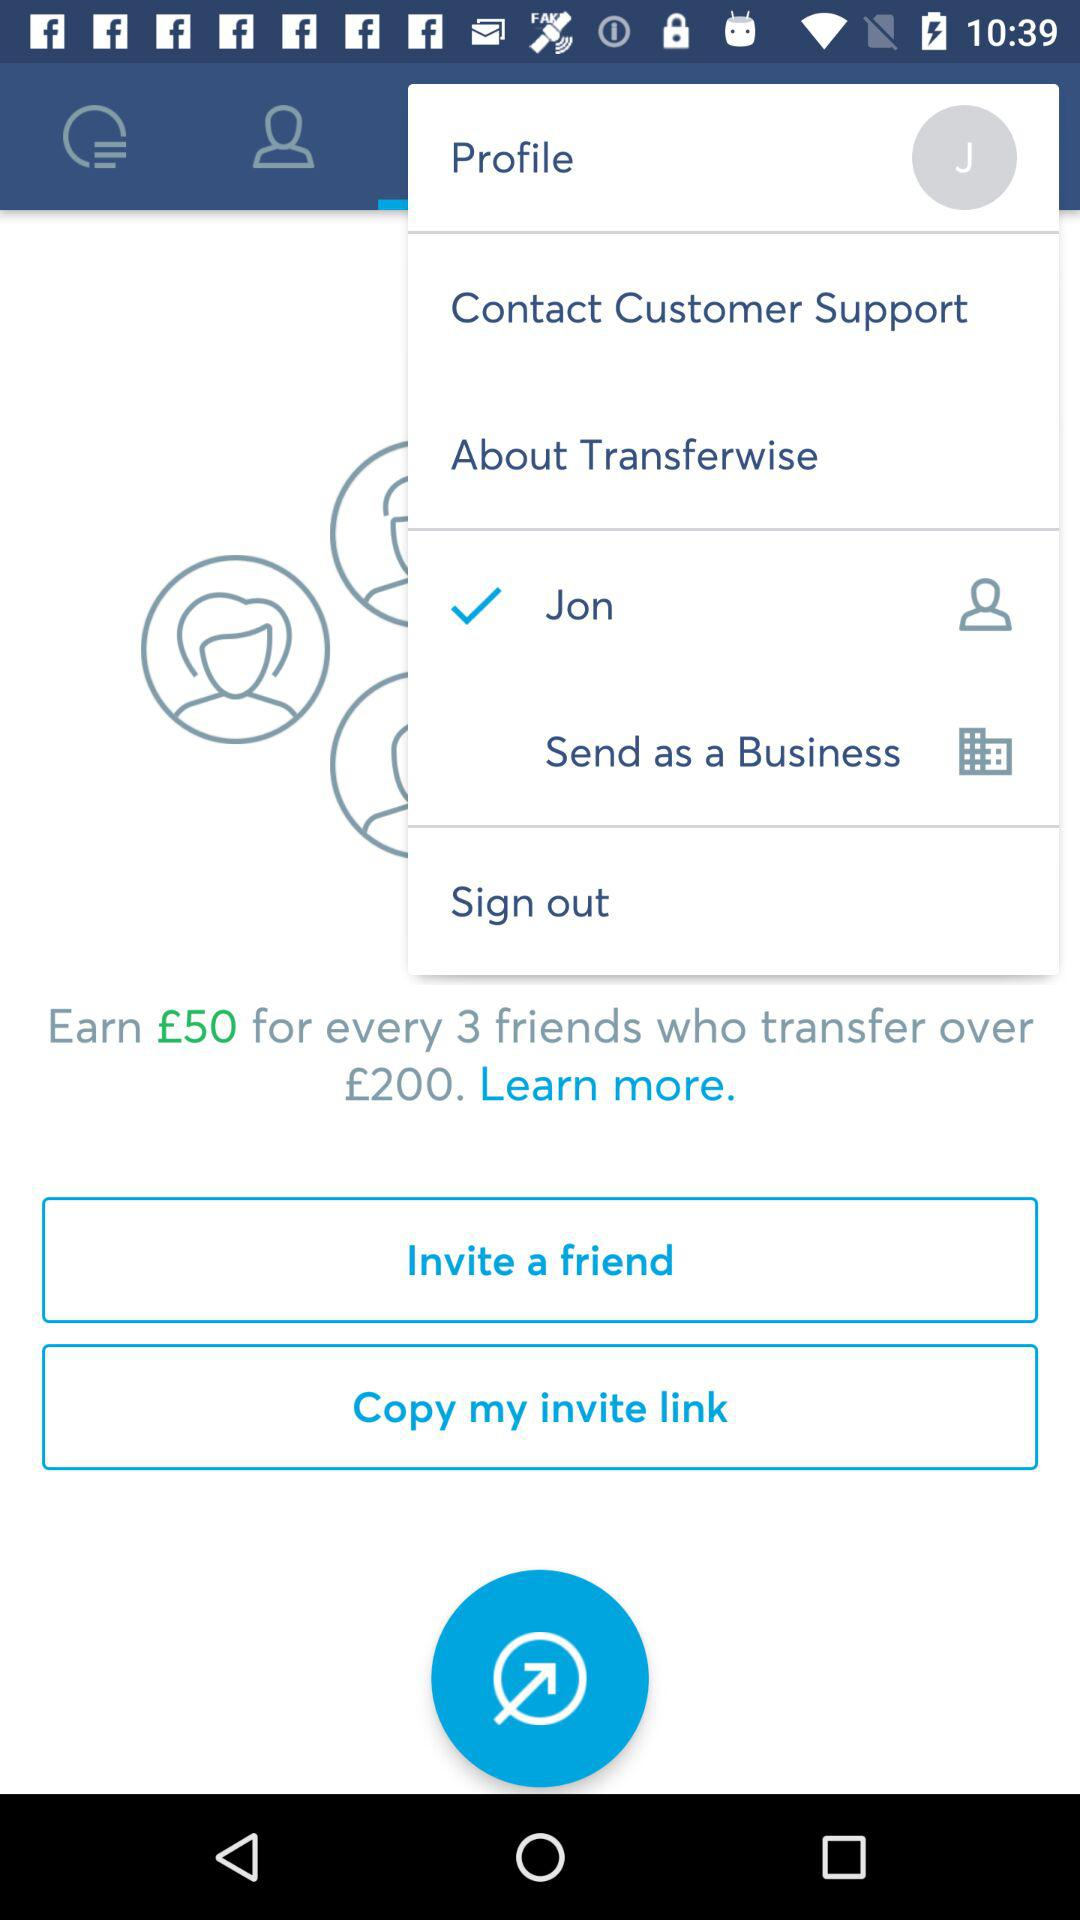What's the user profile name? The user profile name is Jon. 